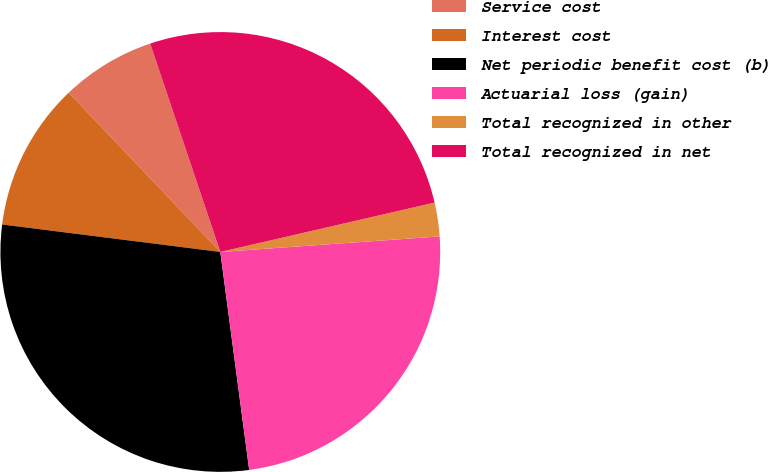<chart> <loc_0><loc_0><loc_500><loc_500><pie_chart><fcel>Service cost<fcel>Interest cost<fcel>Net periodic benefit cost (b)<fcel>Actuarial loss (gain)<fcel>Total recognized in other<fcel>Total recognized in net<nl><fcel>6.94%<fcel>10.9%<fcel>29.09%<fcel>24.03%<fcel>2.48%<fcel>26.56%<nl></chart> 